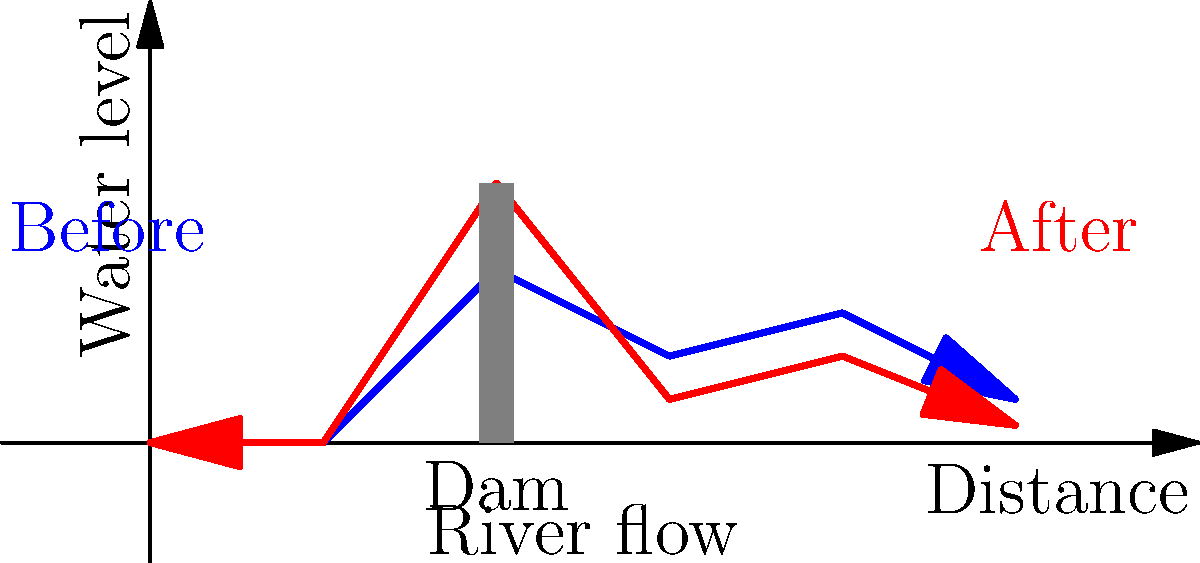Based on the before-and-after diagram of river flow following dam construction, what are the primary ecological concerns for the downstream ecosystem, and how might these impacts be mitigated while still maintaining the dam's intended function? To answer this question, we need to analyze the diagram and consider the ecological implications:

1. Water level changes: 
   - The diagram shows significant fluctuations in water levels downstream of the dam.
   - Before the dam: relatively consistent flow with minor variations.
   - After the dam: sharp increase immediately after the dam, followed by a dramatic drop.

2. Ecological concerns:
   a) Altered flow regime:
      - Natural seasonal variations are disrupted, affecting species adapted to specific flow patterns.
      - Rapid fluctuations can lead to bank erosion and habitat destruction.

   b) Sediment transport:
      - Dams trap sediments, reducing downstream nutrient flow.
      - This can lead to reduced soil fertility in floodplains and delta regions.

   c) Water temperature changes:
      - Deep reservoirs often release colder water, affecting temperature-sensitive species.

   d) Disrupted fish migration:
      - The dam acts as a physical barrier for migratory fish species.

   e) Changes in riparian vegetation:
      - Altered water levels can lead to changes in plant communities along the riverbanks.

3. Mitigation strategies:
   a) Environmental flow releases:
      - Implement a flow regime that mimics natural variations to support ecosystem functions.
      - Use adaptive management to adjust releases based on ecological monitoring.

   b) Sediment management:
      - Periodic flushing of sediments through the dam.
      - Mechanical transport of sediments downstream.

   c) Multi-level water intakes:
      - Allow for release of water from different depths to manage temperature impacts.

   d) Fish passages:
      - Construct fish ladders or other passage structures to allow fish migration.

   e) Riparian restoration:
      - Implement revegetation projects along the riverbanks to stabilize soil and provide habitat.

   f) Operational adjustments:
      - Modify dam operations to reduce rapid fluctuations in water levels.

By implementing these mitigation strategies, it's possible to reduce the ecological impact of the dam while still maintaining its primary functions such as flood control, water supply, or hydroelectric power generation.
Answer: Implement environmental flow releases, sediment management, multi-level water intakes, fish passages, riparian restoration, and operational adjustments to mitigate ecological impacts while maintaining dam functionality. 